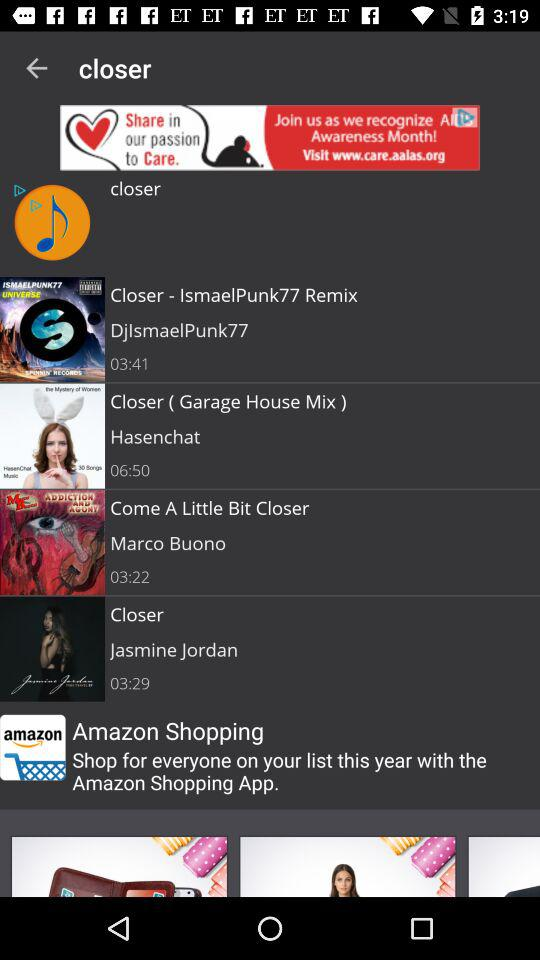Can you provide more information about other tracks shown in the list? Certainly! The image displays several tracks including 'Closer - IsmaelPunk77 Remix' by DjIsmaelPunk77, lasting 3 minutes and 41 seconds, which explores a different, energetic remix style. There's also 'Come A Little Bit Closer' by Marco Buono, a softer track lasting for 3 minutes and 22 seconds, alongside 'Closer' by Jasmine Jordan, which is 3 minutes and 29 seconds long. 